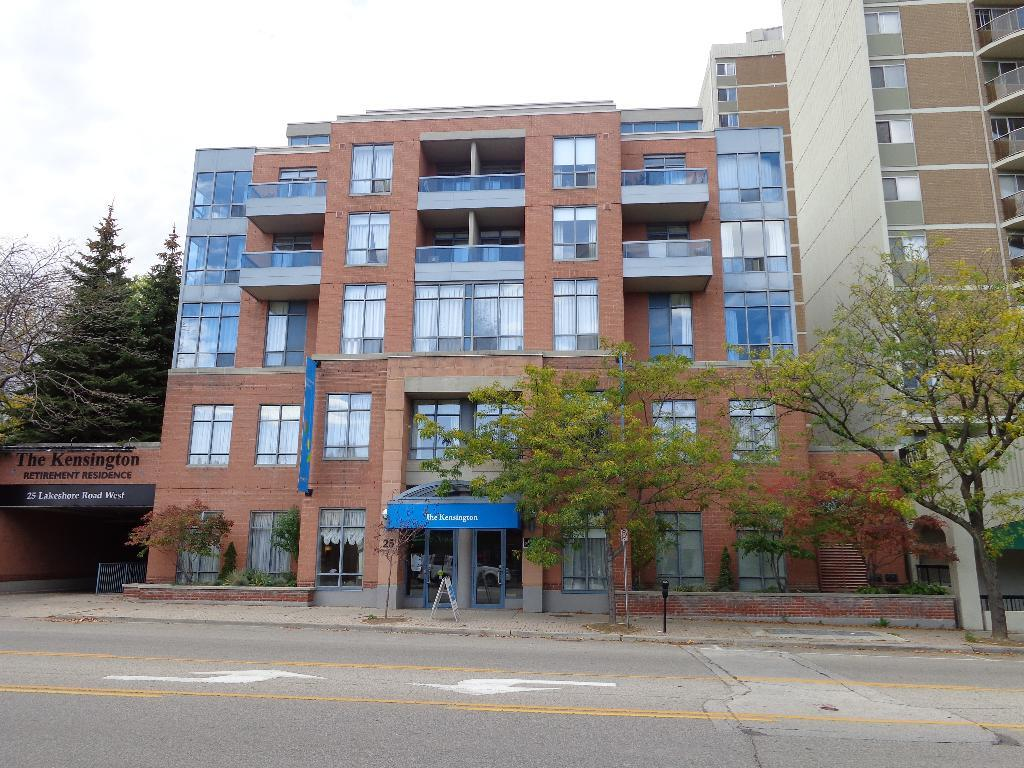What is located in the center of the image? There are buildings in the center of the image. What type of vegetation can be seen on the right side of the image? There are trees on the right side of the image. What type of vegetation can be seen on the left side of the image? There are trees on the left side of the image. Where is the bridge located in the image? There is no bridge present in the image. What type of cake is being served at the event in the image? There is no event or cake present in the image. 